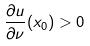Convert formula to latex. <formula><loc_0><loc_0><loc_500><loc_500>\frac { \partial u } { \partial \nu } ( x _ { 0 } ) > 0</formula> 